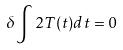<formula> <loc_0><loc_0><loc_500><loc_500>\delta \int 2 T ( t ) d t = 0</formula> 